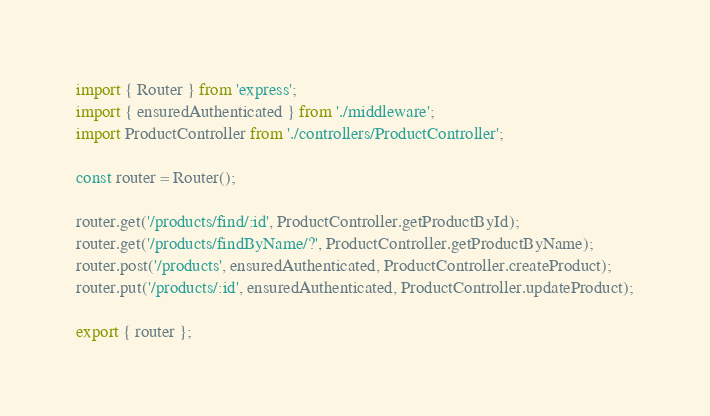Convert code to text. <code><loc_0><loc_0><loc_500><loc_500><_TypeScript_>import { Router } from 'express';
import { ensuredAuthenticated } from './middleware';
import ProductController from './controllers/ProductController';

const router = Router();

router.get('/products/find/:id', ProductController.getProductById);
router.get('/products/findByName/?', ProductController.getProductByName);
router.post('/products', ensuredAuthenticated, ProductController.createProduct);
router.put('/products/:id', ensuredAuthenticated, ProductController.updateProduct);

export { router };
</code> 